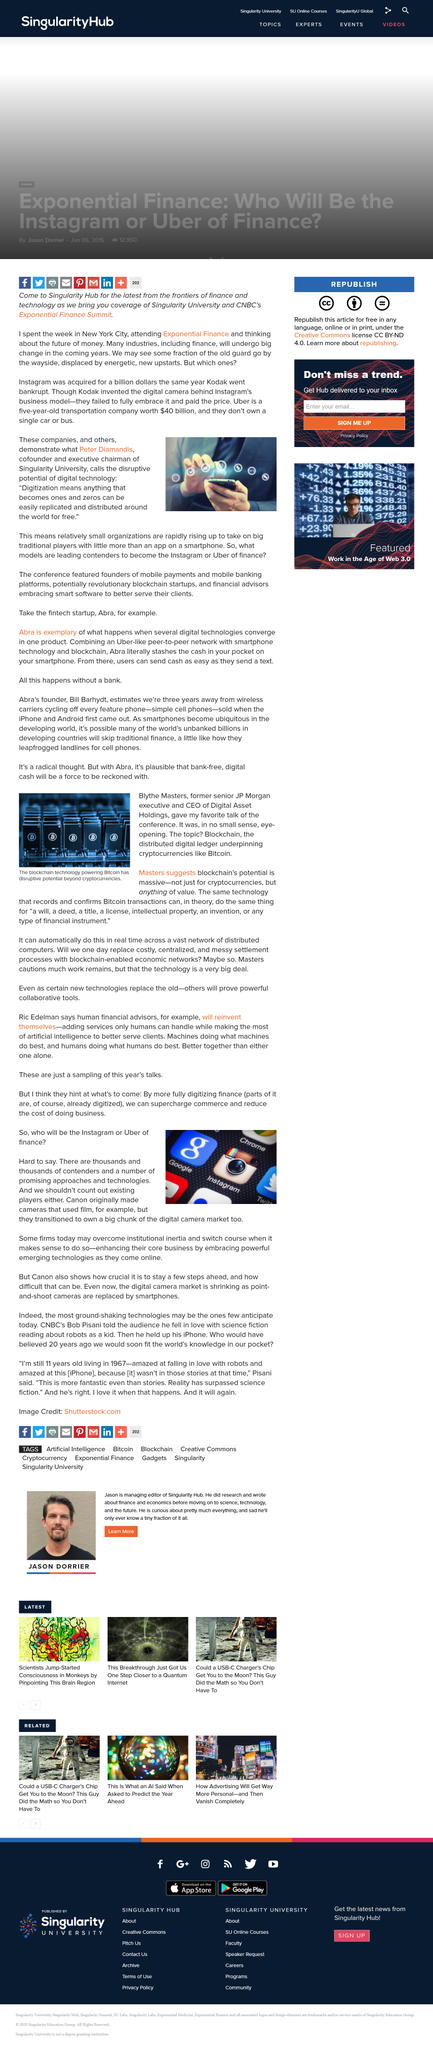Highlight a few significant elements in this photo. Instagram was acquired for a total of one billion dollars. Digital Asset Holdings is led by Blythe Masters as its CEO. The digitization of the finance industry will have a significant impact, enabling enhanced commerce and reducing the cost of doing business. Instagram was acquired for one billion dollars. Firms that successfully overcome institutional inertia will benefit by being able to enhance their core business through the adoption of emerging technologies, leading to increased innovation and competitiveness in their respective industries. 